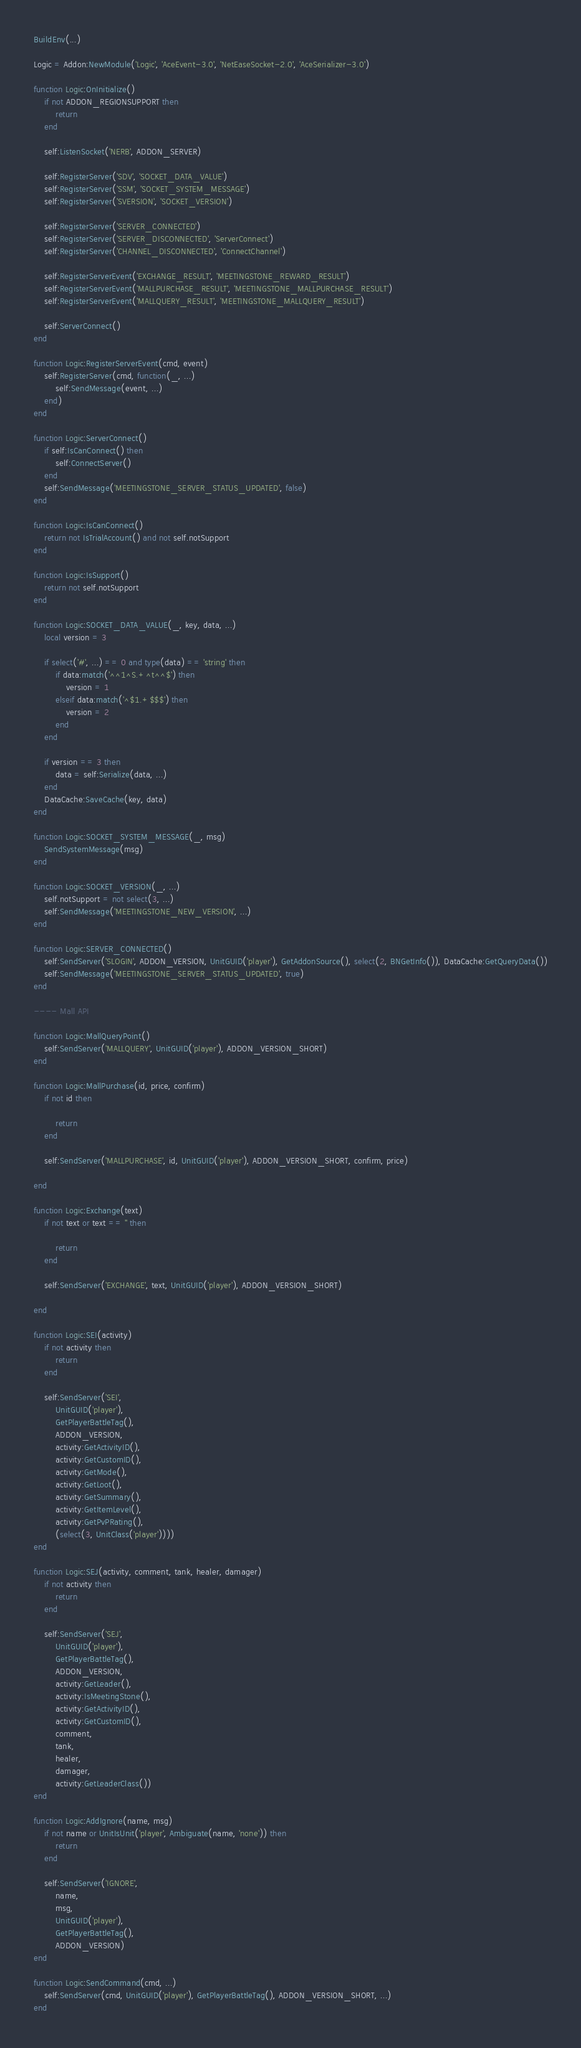<code> <loc_0><loc_0><loc_500><loc_500><_Lua_>
BuildEnv(...)

Logic = Addon:NewModule('Logic', 'AceEvent-3.0', 'NetEaseSocket-2.0', 'AceSerializer-3.0')

function Logic:OnInitialize()
    if not ADDON_REGIONSUPPORT then
        return
    end

    self:ListenSocket('NERB', ADDON_SERVER)

    self:RegisterServer('SDV', 'SOCKET_DATA_VALUE')
    self:RegisterServer('SSM', 'SOCKET_SYSTEM_MESSAGE')
    self:RegisterServer('SVERSION', 'SOCKET_VERSION')

    self:RegisterServer('SERVER_CONNECTED')
    self:RegisterServer('SERVER_DISCONNECTED', 'ServerConnect')
    self:RegisterServer('CHANNEL_DISCONNECTED', 'ConnectChannel')

    self:RegisterServerEvent('EXCHANGE_RESULT', 'MEETINGSTONE_REWARD_RESULT')
    self:RegisterServerEvent('MALLPURCHASE_RESULT', 'MEETINGSTONE_MALLPURCHASE_RESULT')
    self:RegisterServerEvent('MALLQUERY_RESULT', 'MEETINGSTONE_MALLQUERY_RESULT')

    self:ServerConnect()
end

function Logic:RegisterServerEvent(cmd, event)
    self:RegisterServer(cmd, function(_, ...)
        self:SendMessage(event, ...)
    end)
end

function Logic:ServerConnect()
    if self:IsCanConnect() then
        self:ConnectServer()
    end
    self:SendMessage('MEETINGSTONE_SERVER_STATUS_UPDATED', false)
end

function Logic:IsCanConnect()
    return not IsTrialAccount() and not self.notSupport
end

function Logic:IsSupport()
    return not self.notSupport
end

function Logic:SOCKET_DATA_VALUE(_, key, data, ...)
    local version = 3

    if select('#', ...) == 0 and type(data) == 'string' then
        if data:match('^^1^S.+^t^^$') then
            version = 1
        elseif data:match('^$1.+$$$') then
            version = 2
        end
    end

    if version == 3 then
        data = self:Serialize(data, ...)
    end
    DataCache:SaveCache(key, data)
end

function Logic:SOCKET_SYSTEM_MESSAGE(_, msg)
    SendSystemMessage(msg)
end

function Logic:SOCKET_VERSION(_, ...)
    self.notSupport = not select(3, ...)
    self:SendMessage('MEETINGSTONE_NEW_VERSION', ...)
end

function Logic:SERVER_CONNECTED()
    self:SendServer('SLOGIN', ADDON_VERSION, UnitGUID('player'), GetAddonSource(), select(2, BNGetInfo()), DataCache:GetQueryData())
    self:SendMessage('MEETINGSTONE_SERVER_STATUS_UPDATED', true)
end

---- Mall API

function Logic:MallQueryPoint()
    self:SendServer('MALLQUERY', UnitGUID('player'), ADDON_VERSION_SHORT)
end

function Logic:MallPurchase(id, price, confirm)
    if not id then
        
        return
    end

    self:SendServer('MALLPURCHASE', id, UnitGUID('player'), ADDON_VERSION_SHORT, confirm, price)
    
end

function Logic:Exchange(text)
    if not text or text == '' then
        
        return
    end

    self:SendServer('EXCHANGE', text, UnitGUID('player'), ADDON_VERSION_SHORT)
    
end

function Logic:SEI(activity)
    if not activity then
        return
    end

    self:SendServer('SEI',
        UnitGUID('player'),
        GetPlayerBattleTag(),
        ADDON_VERSION,
        activity:GetActivityID(),
        activity:GetCustomID(),
        activity:GetMode(),
        activity:GetLoot(),
        activity:GetSummary(),
        activity:GetItemLevel(),
        activity:GetPvPRating(),
        (select(3, UnitClass('player'))))
end

function Logic:SEJ(activity, comment, tank, healer, damager)
    if not activity then
        return
    end

    self:SendServer('SEJ',
        UnitGUID('player'),
        GetPlayerBattleTag(),
        ADDON_VERSION,
        activity:GetLeader(),
        activity:IsMeetingStone(),
        activity:GetActivityID(),
        activity:GetCustomID(),
        comment,
        tank,
        healer,
        damager,
        activity:GetLeaderClass())
end

function Logic:AddIgnore(name, msg)
    if not name or UnitIsUnit('player', Ambiguate(name, 'none')) then
        return
    end

    self:SendServer('IGNORE',
        name,
        msg,
        UnitGUID('player'),
        GetPlayerBattleTag(),
        ADDON_VERSION)
end

function Logic:SendCommand(cmd, ...)
    self:SendServer(cmd, UnitGUID('player'), GetPlayerBattleTag(), ADDON_VERSION_SHORT, ...)
end
</code> 